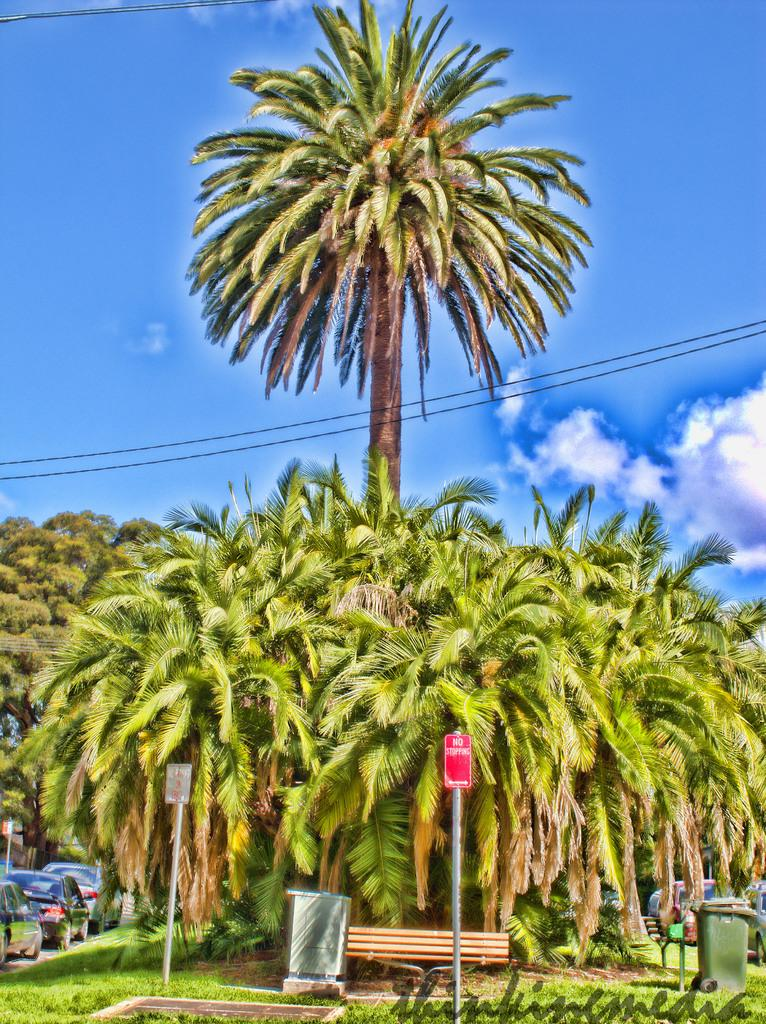What types of objects are on the ground in the image? There are vehicles on the ground in the image. What else can be seen in the image besides the vehicles? There are poles, trees, and some objects in the image. Can you describe the background of the image? The sky is visible in the background of the image, and clouds are present in the sky. Is there a tiger walking on the vehicles in the image? No, there is no tiger present in the image. What type of truck is parked next to the vehicles in the image? There is no truck mentioned in the provided facts, so we cannot answer this question. 